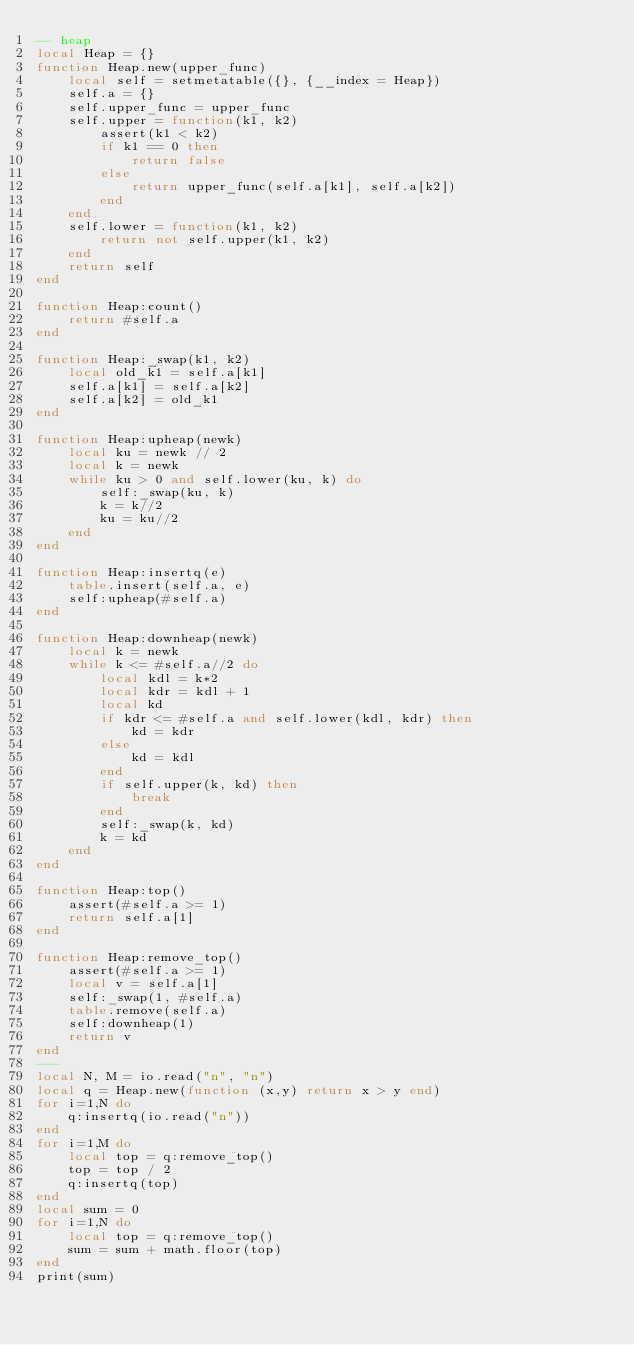<code> <loc_0><loc_0><loc_500><loc_500><_Lua_>-- heap
local Heap = {}
function Heap.new(upper_func)
    local self = setmetatable({}, {__index = Heap})
    self.a = {}
    self.upper_func = upper_func
    self.upper = function(k1, k2)
        assert(k1 < k2)
        if k1 == 0 then
            return false
        else
            return upper_func(self.a[k1], self.a[k2])
        end
    end
    self.lower = function(k1, k2)
        return not self.upper(k1, k2)
    end
    return self
end

function Heap:count()
    return #self.a
end

function Heap:_swap(k1, k2)
    local old_k1 = self.a[k1]
    self.a[k1] = self.a[k2]
    self.a[k2] = old_k1
end

function Heap:upheap(newk)
    local ku = newk // 2
    local k = newk
    while ku > 0 and self.lower(ku, k) do
        self:_swap(ku, k)
        k = k//2
        ku = ku//2
    end
end

function Heap:insertq(e)
    table.insert(self.a, e)
    self:upheap(#self.a)
end

function Heap:downheap(newk)
    local k = newk
    while k <= #self.a//2 do
        local kdl = k*2
        local kdr = kdl + 1
        local kd
        if kdr <= #self.a and self.lower(kdl, kdr) then
            kd = kdr
        else
            kd = kdl
        end
        if self.upper(k, kd) then
            break
        end
        self:_swap(k, kd)
        k = kd
    end
end

function Heap:top()
    assert(#self.a >= 1)
    return self.a[1]
end

function Heap:remove_top()
    assert(#self.a >= 1)
    local v = self.a[1]
    self:_swap(1, #self.a)
    table.remove(self.a)
    self:downheap(1)
    return v
end
---
local N, M = io.read("n", "n")
local q = Heap.new(function (x,y) return x > y end)
for i=1,N do
    q:insertq(io.read("n"))
end
for i=1,M do
    local top = q:remove_top()
    top = top / 2
    q:insertq(top)
end
local sum = 0
for i=1,N do
    local top = q:remove_top()
    sum = sum + math.floor(top)
end
print(sum)</code> 